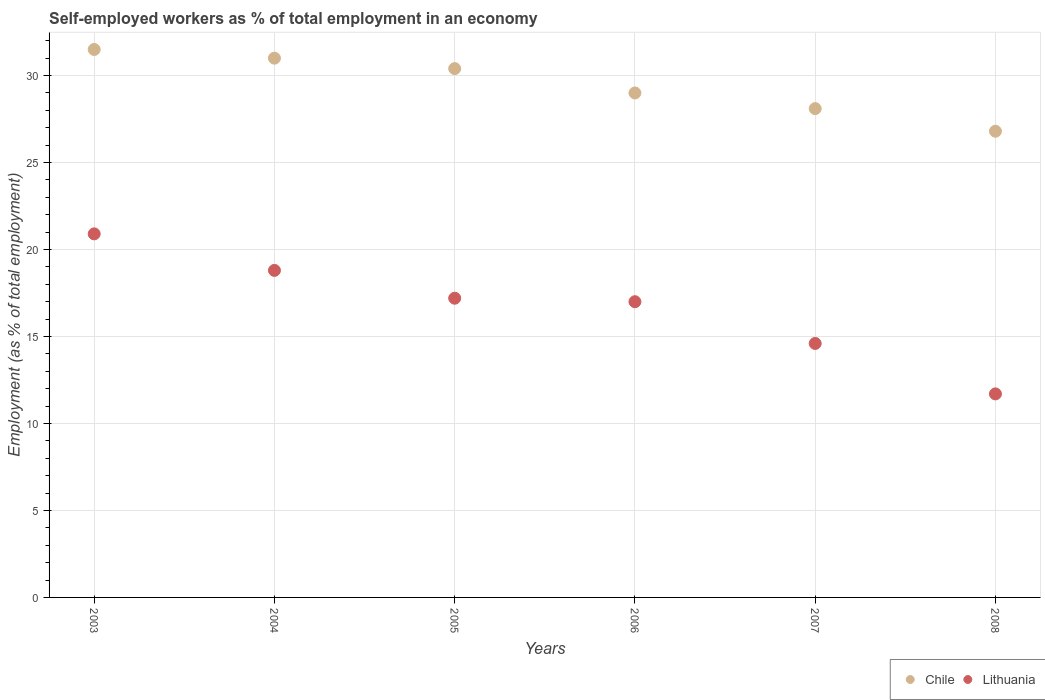Is the number of dotlines equal to the number of legend labels?
Provide a short and direct response. Yes. What is the percentage of self-employed workers in Chile in 2008?
Offer a very short reply. 26.8. Across all years, what is the maximum percentage of self-employed workers in Lithuania?
Make the answer very short. 20.9. Across all years, what is the minimum percentage of self-employed workers in Lithuania?
Your answer should be very brief. 11.7. In which year was the percentage of self-employed workers in Lithuania maximum?
Your answer should be very brief. 2003. What is the total percentage of self-employed workers in Lithuania in the graph?
Offer a very short reply. 100.2. What is the difference between the percentage of self-employed workers in Lithuania in 2005 and that in 2007?
Keep it short and to the point. 2.6. What is the difference between the percentage of self-employed workers in Chile in 2006 and the percentage of self-employed workers in Lithuania in 2005?
Your answer should be compact. 11.8. What is the average percentage of self-employed workers in Lithuania per year?
Offer a terse response. 16.7. In the year 2004, what is the difference between the percentage of self-employed workers in Chile and percentage of self-employed workers in Lithuania?
Keep it short and to the point. 12.2. In how many years, is the percentage of self-employed workers in Chile greater than 1 %?
Your response must be concise. 6. What is the ratio of the percentage of self-employed workers in Chile in 2004 to that in 2008?
Provide a succinct answer. 1.16. Is the difference between the percentage of self-employed workers in Chile in 2003 and 2005 greater than the difference between the percentage of self-employed workers in Lithuania in 2003 and 2005?
Make the answer very short. No. What is the difference between the highest and the lowest percentage of self-employed workers in Lithuania?
Your response must be concise. 9.2. Is the sum of the percentage of self-employed workers in Chile in 2003 and 2007 greater than the maximum percentage of self-employed workers in Lithuania across all years?
Provide a succinct answer. Yes. Does the percentage of self-employed workers in Chile monotonically increase over the years?
Ensure brevity in your answer.  No. Is the percentage of self-employed workers in Lithuania strictly greater than the percentage of self-employed workers in Chile over the years?
Your response must be concise. No. Is the percentage of self-employed workers in Lithuania strictly less than the percentage of self-employed workers in Chile over the years?
Make the answer very short. Yes. How many dotlines are there?
Provide a succinct answer. 2. Are the values on the major ticks of Y-axis written in scientific E-notation?
Keep it short and to the point. No. Does the graph contain any zero values?
Ensure brevity in your answer.  No. Does the graph contain grids?
Keep it short and to the point. Yes. Where does the legend appear in the graph?
Provide a short and direct response. Bottom right. What is the title of the graph?
Keep it short and to the point. Self-employed workers as % of total employment in an economy. Does "Latvia" appear as one of the legend labels in the graph?
Your answer should be compact. No. What is the label or title of the Y-axis?
Give a very brief answer. Employment (as % of total employment). What is the Employment (as % of total employment) of Chile in 2003?
Ensure brevity in your answer.  31.5. What is the Employment (as % of total employment) of Lithuania in 2003?
Offer a terse response. 20.9. What is the Employment (as % of total employment) of Chile in 2004?
Provide a succinct answer. 31. What is the Employment (as % of total employment) in Lithuania in 2004?
Your answer should be compact. 18.8. What is the Employment (as % of total employment) in Chile in 2005?
Provide a succinct answer. 30.4. What is the Employment (as % of total employment) in Lithuania in 2005?
Provide a succinct answer. 17.2. What is the Employment (as % of total employment) in Chile in 2006?
Offer a very short reply. 29. What is the Employment (as % of total employment) of Lithuania in 2006?
Give a very brief answer. 17. What is the Employment (as % of total employment) of Chile in 2007?
Offer a very short reply. 28.1. What is the Employment (as % of total employment) of Lithuania in 2007?
Give a very brief answer. 14.6. What is the Employment (as % of total employment) in Chile in 2008?
Offer a terse response. 26.8. What is the Employment (as % of total employment) of Lithuania in 2008?
Your response must be concise. 11.7. Across all years, what is the maximum Employment (as % of total employment) of Chile?
Provide a short and direct response. 31.5. Across all years, what is the maximum Employment (as % of total employment) in Lithuania?
Make the answer very short. 20.9. Across all years, what is the minimum Employment (as % of total employment) of Chile?
Provide a short and direct response. 26.8. Across all years, what is the minimum Employment (as % of total employment) in Lithuania?
Ensure brevity in your answer.  11.7. What is the total Employment (as % of total employment) in Chile in the graph?
Your answer should be compact. 176.8. What is the total Employment (as % of total employment) of Lithuania in the graph?
Offer a very short reply. 100.2. What is the difference between the Employment (as % of total employment) of Chile in 2003 and that in 2004?
Make the answer very short. 0.5. What is the difference between the Employment (as % of total employment) in Chile in 2003 and that in 2006?
Ensure brevity in your answer.  2.5. What is the difference between the Employment (as % of total employment) of Lithuania in 2003 and that in 2006?
Your answer should be very brief. 3.9. What is the difference between the Employment (as % of total employment) in Chile in 2003 and that in 2008?
Provide a short and direct response. 4.7. What is the difference between the Employment (as % of total employment) in Lithuania in 2003 and that in 2008?
Your response must be concise. 9.2. What is the difference between the Employment (as % of total employment) of Chile in 2004 and that in 2005?
Provide a short and direct response. 0.6. What is the difference between the Employment (as % of total employment) of Lithuania in 2004 and that in 2005?
Your response must be concise. 1.6. What is the difference between the Employment (as % of total employment) in Lithuania in 2004 and that in 2006?
Ensure brevity in your answer.  1.8. What is the difference between the Employment (as % of total employment) of Chile in 2004 and that in 2007?
Your response must be concise. 2.9. What is the difference between the Employment (as % of total employment) in Chile in 2004 and that in 2008?
Ensure brevity in your answer.  4.2. What is the difference between the Employment (as % of total employment) of Lithuania in 2005 and that in 2007?
Ensure brevity in your answer.  2.6. What is the difference between the Employment (as % of total employment) of Lithuania in 2005 and that in 2008?
Keep it short and to the point. 5.5. What is the difference between the Employment (as % of total employment) in Chile in 2006 and that in 2007?
Provide a succinct answer. 0.9. What is the difference between the Employment (as % of total employment) in Lithuania in 2006 and that in 2007?
Your response must be concise. 2.4. What is the difference between the Employment (as % of total employment) in Chile in 2007 and that in 2008?
Keep it short and to the point. 1.3. What is the difference between the Employment (as % of total employment) in Chile in 2003 and the Employment (as % of total employment) in Lithuania in 2004?
Make the answer very short. 12.7. What is the difference between the Employment (as % of total employment) in Chile in 2003 and the Employment (as % of total employment) in Lithuania in 2005?
Your answer should be compact. 14.3. What is the difference between the Employment (as % of total employment) in Chile in 2003 and the Employment (as % of total employment) in Lithuania in 2006?
Make the answer very short. 14.5. What is the difference between the Employment (as % of total employment) in Chile in 2003 and the Employment (as % of total employment) in Lithuania in 2007?
Your answer should be compact. 16.9. What is the difference between the Employment (as % of total employment) of Chile in 2003 and the Employment (as % of total employment) of Lithuania in 2008?
Give a very brief answer. 19.8. What is the difference between the Employment (as % of total employment) of Chile in 2004 and the Employment (as % of total employment) of Lithuania in 2005?
Your answer should be compact. 13.8. What is the difference between the Employment (as % of total employment) of Chile in 2004 and the Employment (as % of total employment) of Lithuania in 2006?
Offer a terse response. 14. What is the difference between the Employment (as % of total employment) of Chile in 2004 and the Employment (as % of total employment) of Lithuania in 2007?
Give a very brief answer. 16.4. What is the difference between the Employment (as % of total employment) in Chile in 2004 and the Employment (as % of total employment) in Lithuania in 2008?
Keep it short and to the point. 19.3. What is the difference between the Employment (as % of total employment) of Chile in 2005 and the Employment (as % of total employment) of Lithuania in 2006?
Keep it short and to the point. 13.4. What is the difference between the Employment (as % of total employment) of Chile in 2005 and the Employment (as % of total employment) of Lithuania in 2008?
Offer a very short reply. 18.7. What is the difference between the Employment (as % of total employment) of Chile in 2006 and the Employment (as % of total employment) of Lithuania in 2007?
Provide a succinct answer. 14.4. What is the average Employment (as % of total employment) in Chile per year?
Offer a terse response. 29.47. In the year 2005, what is the difference between the Employment (as % of total employment) of Chile and Employment (as % of total employment) of Lithuania?
Offer a terse response. 13.2. In the year 2007, what is the difference between the Employment (as % of total employment) of Chile and Employment (as % of total employment) of Lithuania?
Your response must be concise. 13.5. In the year 2008, what is the difference between the Employment (as % of total employment) in Chile and Employment (as % of total employment) in Lithuania?
Offer a terse response. 15.1. What is the ratio of the Employment (as % of total employment) in Chile in 2003 to that in 2004?
Your response must be concise. 1.02. What is the ratio of the Employment (as % of total employment) in Lithuania in 2003 to that in 2004?
Make the answer very short. 1.11. What is the ratio of the Employment (as % of total employment) of Chile in 2003 to that in 2005?
Keep it short and to the point. 1.04. What is the ratio of the Employment (as % of total employment) in Lithuania in 2003 to that in 2005?
Offer a terse response. 1.22. What is the ratio of the Employment (as % of total employment) in Chile in 2003 to that in 2006?
Your response must be concise. 1.09. What is the ratio of the Employment (as % of total employment) in Lithuania in 2003 to that in 2006?
Provide a short and direct response. 1.23. What is the ratio of the Employment (as % of total employment) in Chile in 2003 to that in 2007?
Keep it short and to the point. 1.12. What is the ratio of the Employment (as % of total employment) of Lithuania in 2003 to that in 2007?
Offer a very short reply. 1.43. What is the ratio of the Employment (as % of total employment) in Chile in 2003 to that in 2008?
Offer a very short reply. 1.18. What is the ratio of the Employment (as % of total employment) of Lithuania in 2003 to that in 2008?
Provide a succinct answer. 1.79. What is the ratio of the Employment (as % of total employment) in Chile in 2004 to that in 2005?
Make the answer very short. 1.02. What is the ratio of the Employment (as % of total employment) in Lithuania in 2004 to that in 2005?
Your response must be concise. 1.09. What is the ratio of the Employment (as % of total employment) of Chile in 2004 to that in 2006?
Provide a short and direct response. 1.07. What is the ratio of the Employment (as % of total employment) in Lithuania in 2004 to that in 2006?
Keep it short and to the point. 1.11. What is the ratio of the Employment (as % of total employment) of Chile in 2004 to that in 2007?
Ensure brevity in your answer.  1.1. What is the ratio of the Employment (as % of total employment) of Lithuania in 2004 to that in 2007?
Offer a terse response. 1.29. What is the ratio of the Employment (as % of total employment) of Chile in 2004 to that in 2008?
Your response must be concise. 1.16. What is the ratio of the Employment (as % of total employment) in Lithuania in 2004 to that in 2008?
Your answer should be very brief. 1.61. What is the ratio of the Employment (as % of total employment) in Chile in 2005 to that in 2006?
Your answer should be compact. 1.05. What is the ratio of the Employment (as % of total employment) of Lithuania in 2005 to that in 2006?
Offer a terse response. 1.01. What is the ratio of the Employment (as % of total employment) of Chile in 2005 to that in 2007?
Offer a terse response. 1.08. What is the ratio of the Employment (as % of total employment) in Lithuania in 2005 to that in 2007?
Your answer should be very brief. 1.18. What is the ratio of the Employment (as % of total employment) of Chile in 2005 to that in 2008?
Your answer should be compact. 1.13. What is the ratio of the Employment (as % of total employment) of Lithuania in 2005 to that in 2008?
Provide a succinct answer. 1.47. What is the ratio of the Employment (as % of total employment) of Chile in 2006 to that in 2007?
Provide a succinct answer. 1.03. What is the ratio of the Employment (as % of total employment) of Lithuania in 2006 to that in 2007?
Keep it short and to the point. 1.16. What is the ratio of the Employment (as % of total employment) of Chile in 2006 to that in 2008?
Provide a succinct answer. 1.08. What is the ratio of the Employment (as % of total employment) in Lithuania in 2006 to that in 2008?
Your answer should be very brief. 1.45. What is the ratio of the Employment (as % of total employment) of Chile in 2007 to that in 2008?
Provide a succinct answer. 1.05. What is the ratio of the Employment (as % of total employment) of Lithuania in 2007 to that in 2008?
Your answer should be compact. 1.25. What is the difference between the highest and the second highest Employment (as % of total employment) in Lithuania?
Provide a short and direct response. 2.1. What is the difference between the highest and the lowest Employment (as % of total employment) in Lithuania?
Provide a succinct answer. 9.2. 